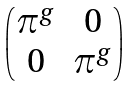<formula> <loc_0><loc_0><loc_500><loc_500>\begin{pmatrix} \pi ^ { g } & 0 \\ 0 & \pi ^ { g } \end{pmatrix}</formula> 